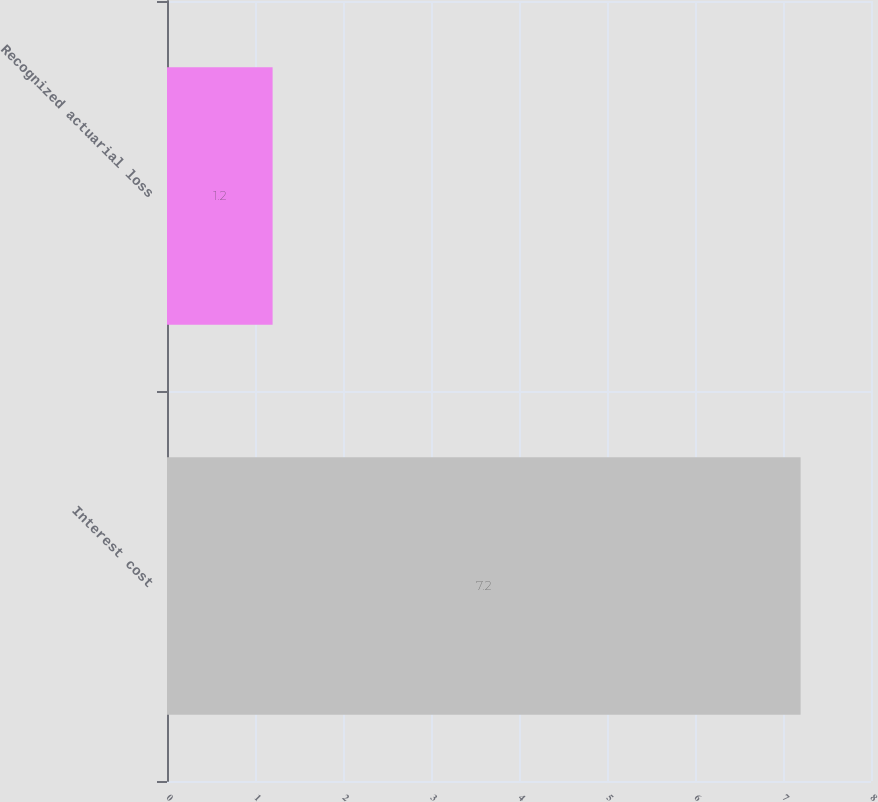Convert chart. <chart><loc_0><loc_0><loc_500><loc_500><bar_chart><fcel>Interest cost<fcel>Recognized actuarial loss<nl><fcel>7.2<fcel>1.2<nl></chart> 